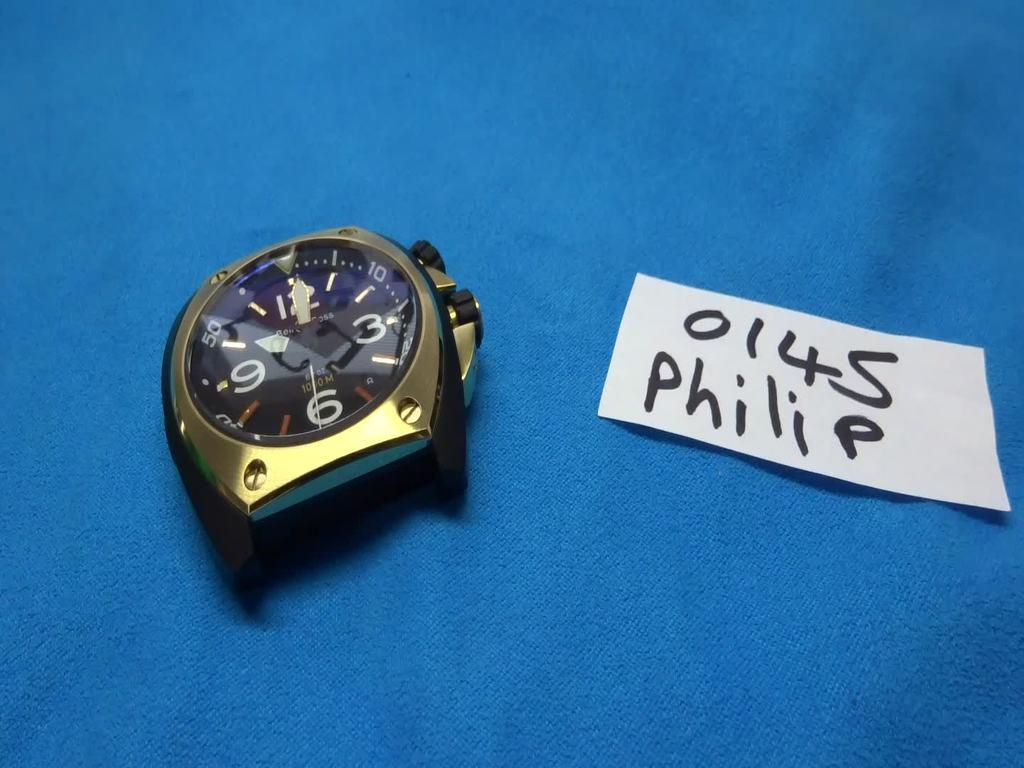Provide a one-sentence caption for the provided image. Part of a wristwatch next to a white label which says 0145 Philip. 